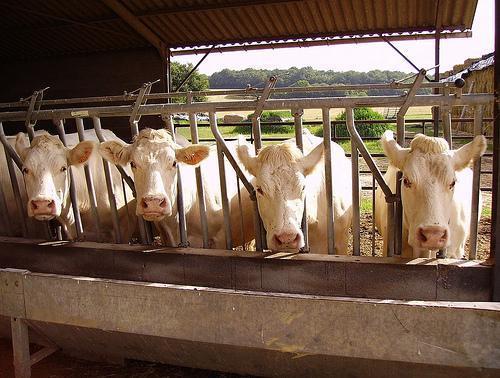How many cows are there?
Give a very brief answer. 4. 